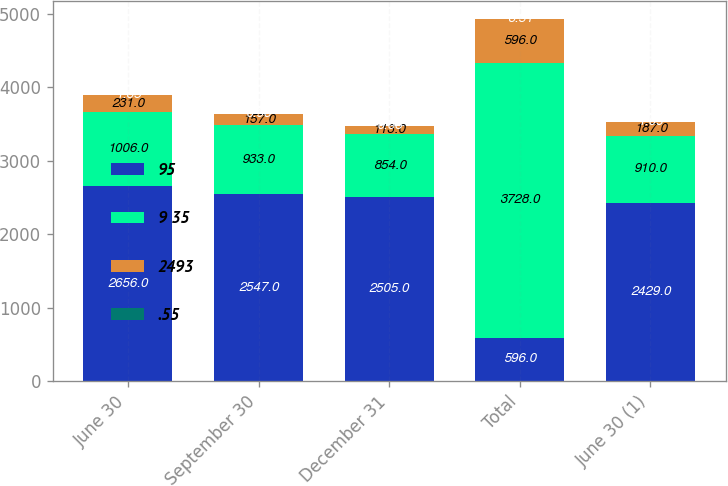Convert chart. <chart><loc_0><loc_0><loc_500><loc_500><stacked_bar_chart><ecel><fcel>June 30<fcel>September 30<fcel>December 31<fcel>Total<fcel>June 30 (1)<nl><fcel>95<fcel>2656<fcel>2547<fcel>2505<fcel>596<fcel>2429<nl><fcel>9 35<fcel>1006<fcel>933<fcel>854<fcel>3728<fcel>910<nl><fcel>2493<fcel>231<fcel>157<fcel>113<fcel>596<fcel>187<nl><fcel>.55<fcel>1.35<fcel>0.93<fcel>0.68<fcel>3.51<fcel>1.09<nl></chart> 